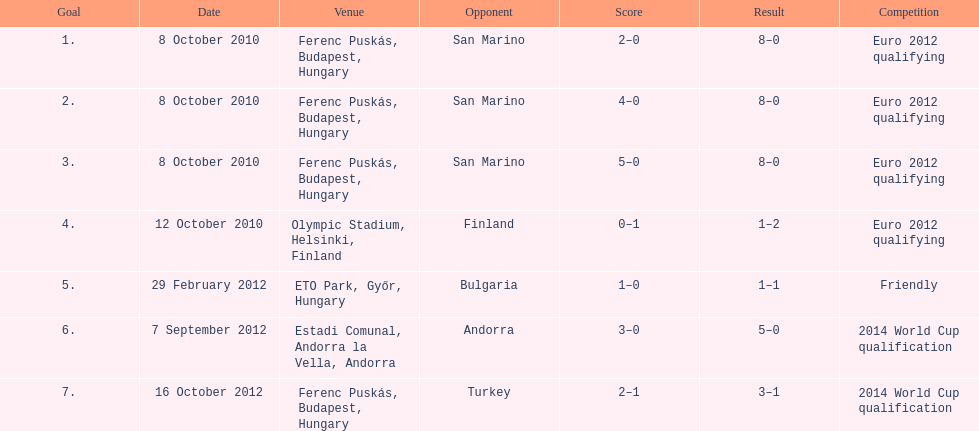In how many non-qualifying matches did he make a score? 1. 